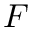<formula> <loc_0><loc_0><loc_500><loc_500>F</formula> 